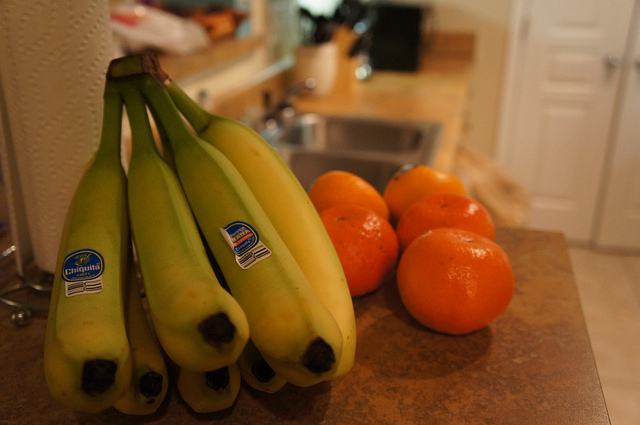What can you tell me about the setting of this image? The photo seems to be taken in a home kitchen, as you can spot domestic items like a sink, a liquid soap dispenser, and what seems to be a fridge in the background, indicating a cozy and familiar environment.  Are there any other details that might tell us more about when this image was taken? The lighting in the image suggests indoor illumination, possibly in the evening as there's no sign of natural daylight. The freshness of the bananas and oranges suggest the photo was possibly taken soon after grocery shopping. 